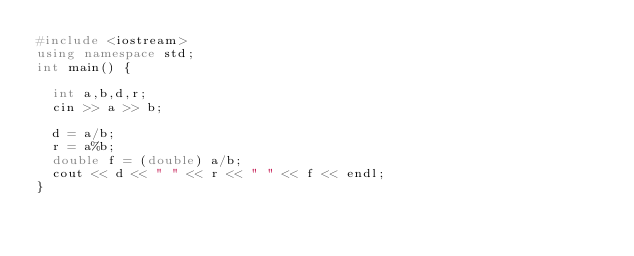<code> <loc_0><loc_0><loc_500><loc_500><_C++_>#include <iostream>
using namespace std;
int main() {

	int a,b,d,r;
	cin >> a >> b;
	
	d = a/b;
	r = a%b;
	double f = (double) a/b;
	cout << d << " " << r << " " << f << endl; 
}</code> 